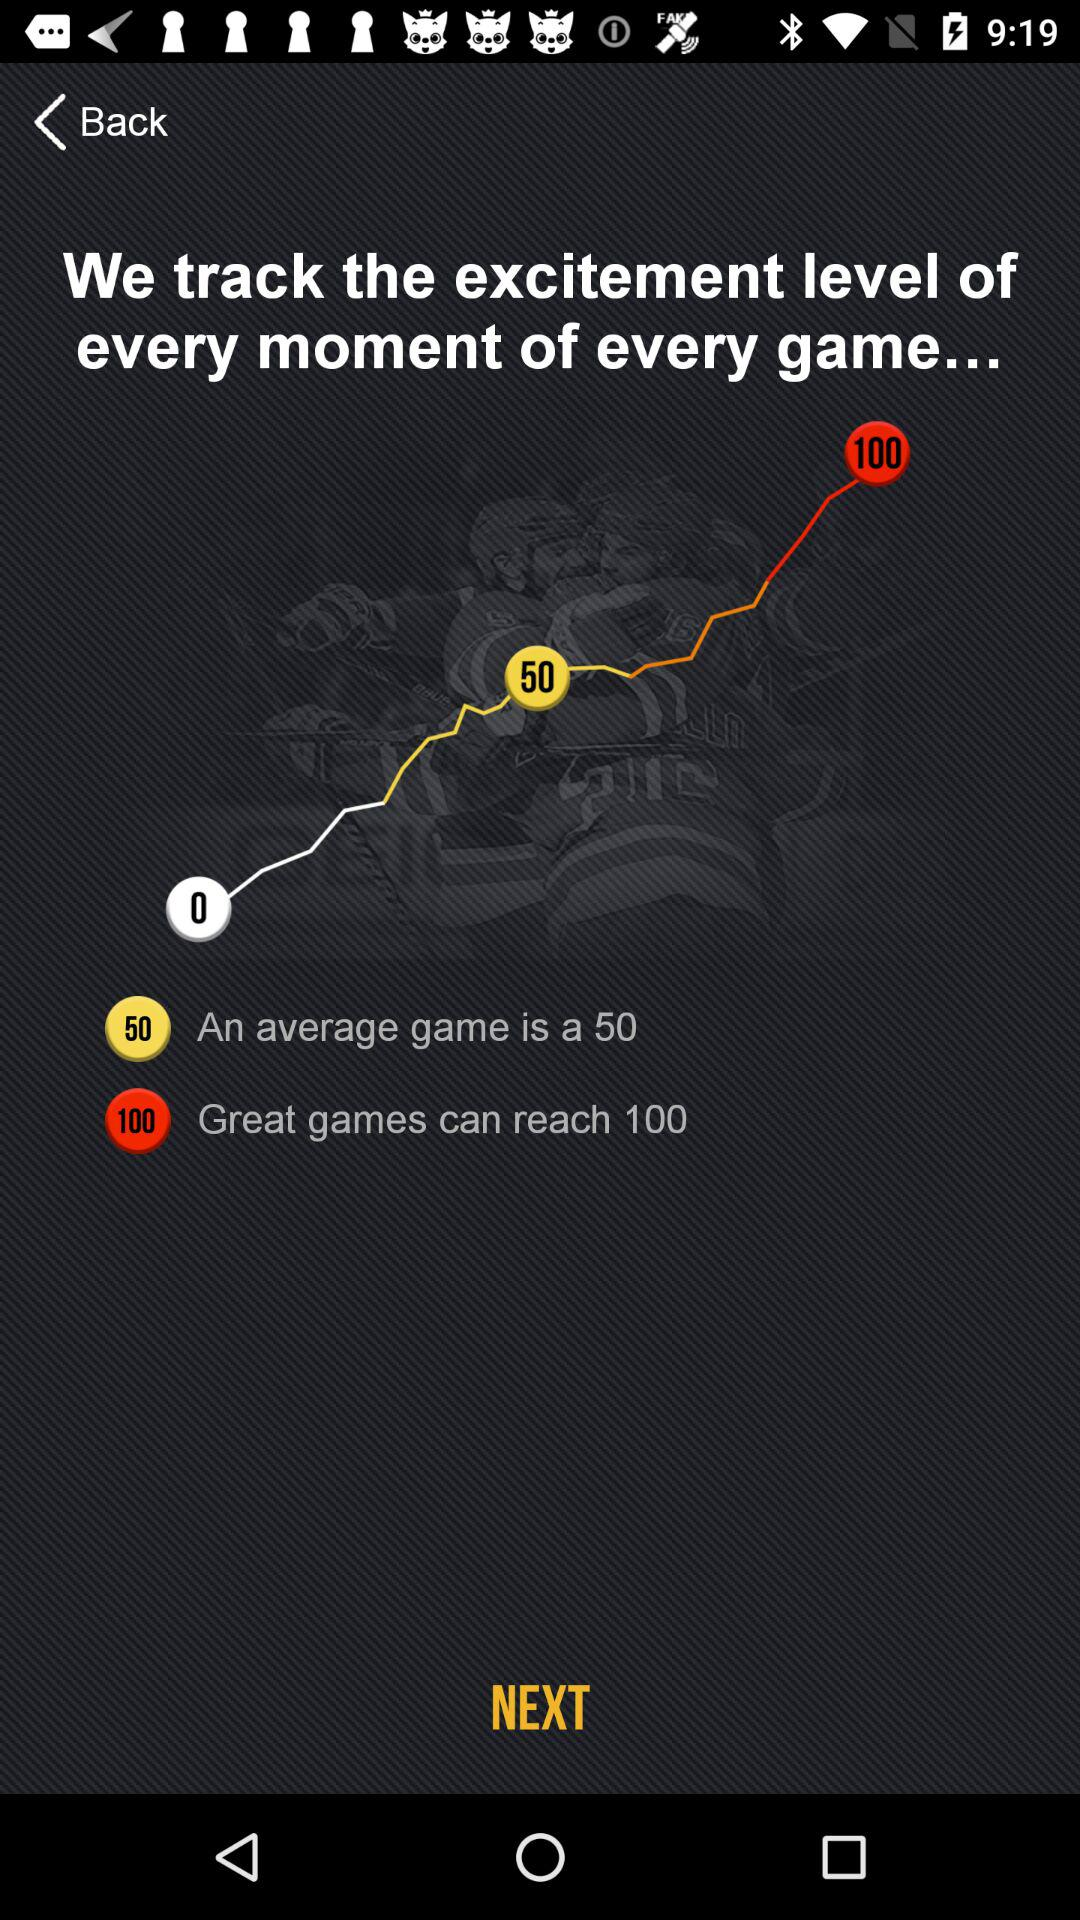What level do "Great games" reach? The level is 100 for great games. 